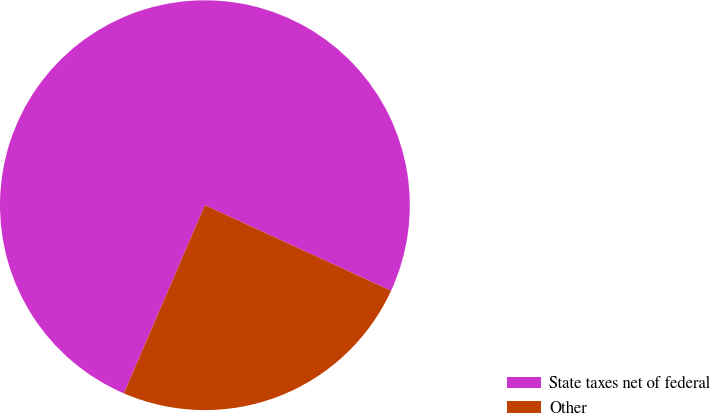Convert chart to OTSL. <chart><loc_0><loc_0><loc_500><loc_500><pie_chart><fcel>State taxes net of federal<fcel>Other<nl><fcel>75.38%<fcel>24.62%<nl></chart> 